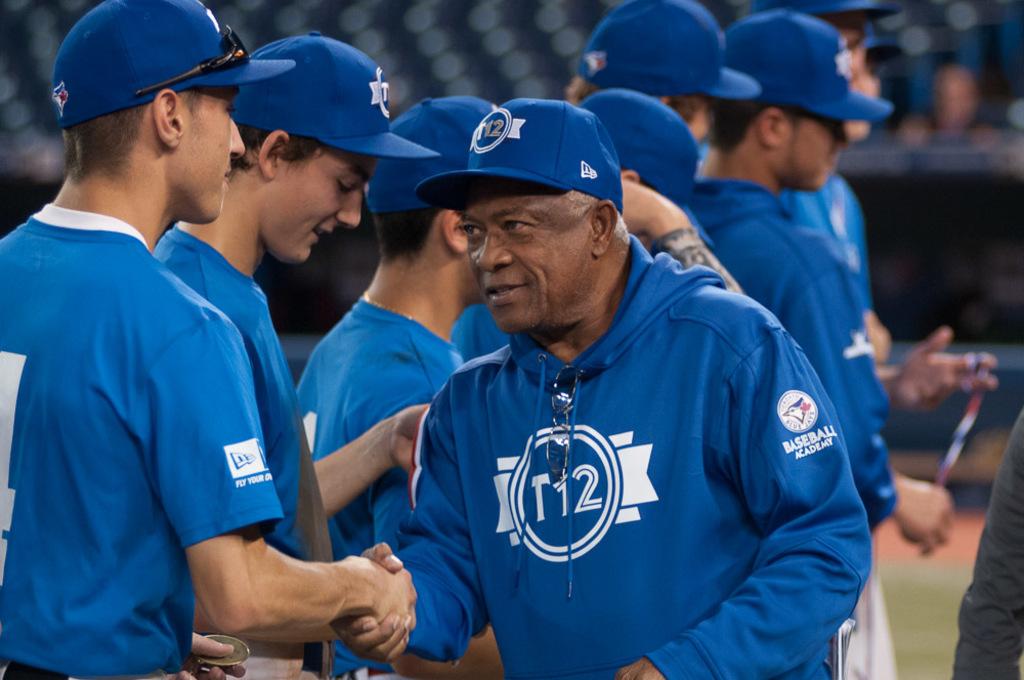What sport name is written on the man's sleeve?
Make the answer very short. Baseball. 